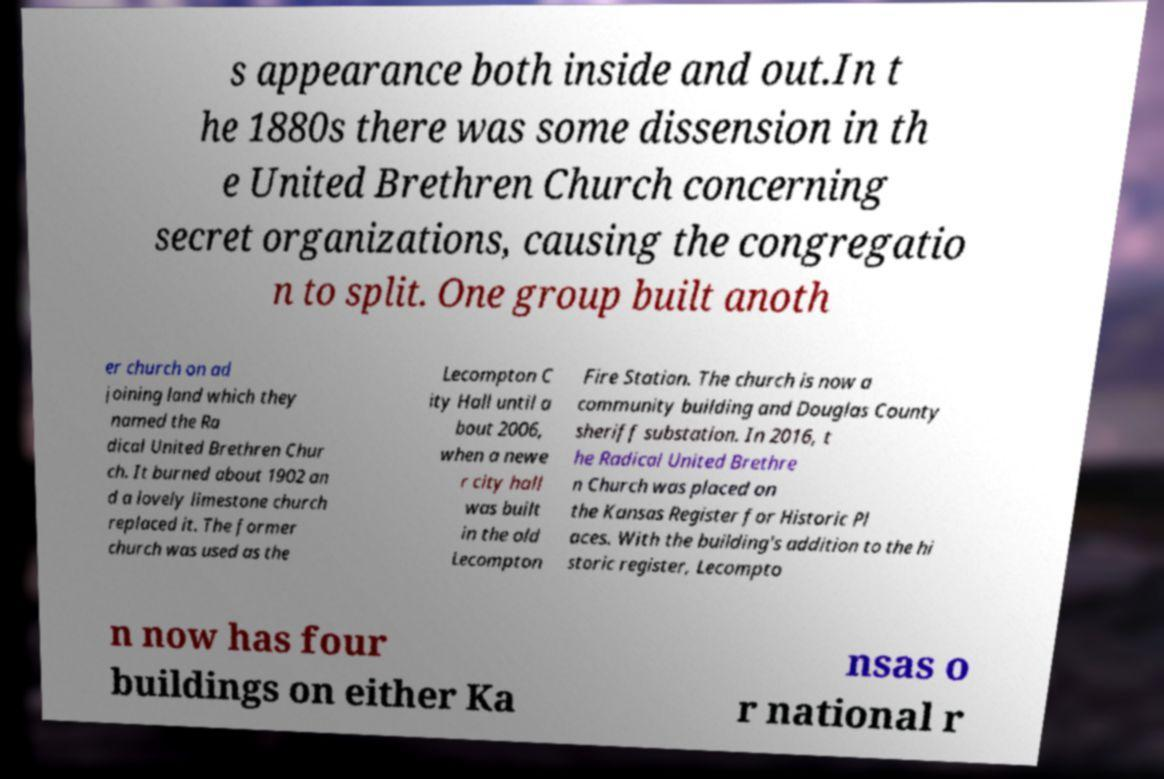I need the written content from this picture converted into text. Can you do that? s appearance both inside and out.In t he 1880s there was some dissension in th e United Brethren Church concerning secret organizations, causing the congregatio n to split. One group built anoth er church on ad joining land which they named the Ra dical United Brethren Chur ch. It burned about 1902 an d a lovely limestone church replaced it. The former church was used as the Lecompton C ity Hall until a bout 2006, when a newe r city hall was built in the old Lecompton Fire Station. The church is now a community building and Douglas County sheriff substation. In 2016, t he Radical United Brethre n Church was placed on the Kansas Register for Historic Pl aces. With the building's addition to the hi storic register, Lecompto n now has four buildings on either Ka nsas o r national r 